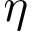<formula> <loc_0><loc_0><loc_500><loc_500>\eta</formula> 